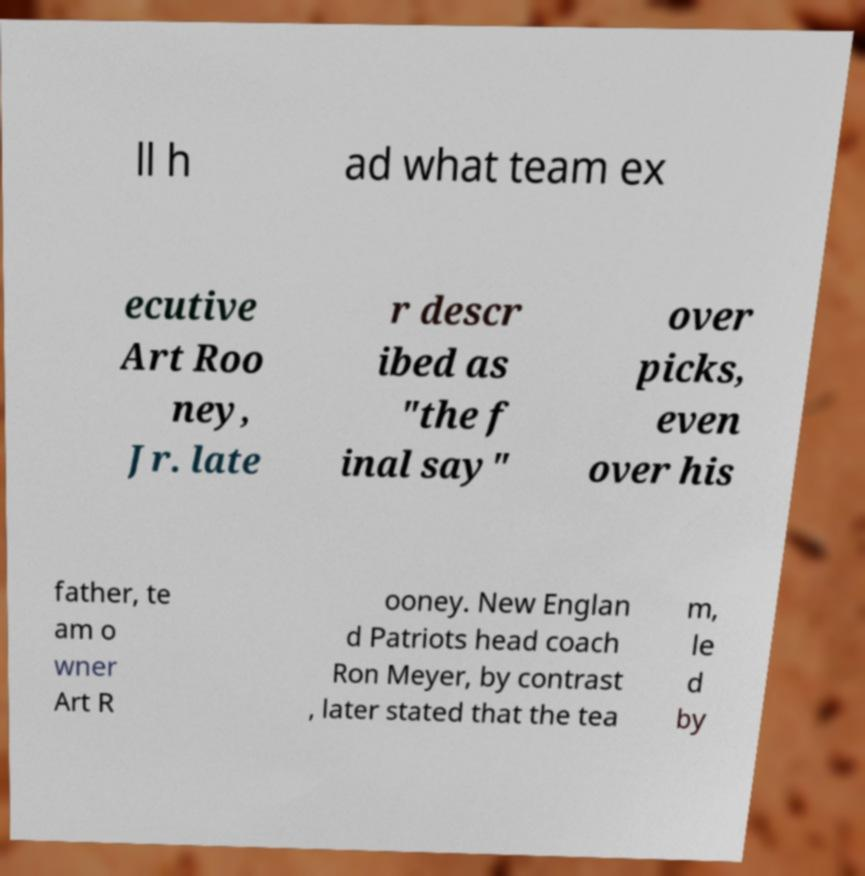Can you accurately transcribe the text from the provided image for me? ll h ad what team ex ecutive Art Roo ney, Jr. late r descr ibed as "the f inal say" over picks, even over his father, te am o wner Art R ooney. New Englan d Patriots head coach Ron Meyer, by contrast , later stated that the tea m, le d by 